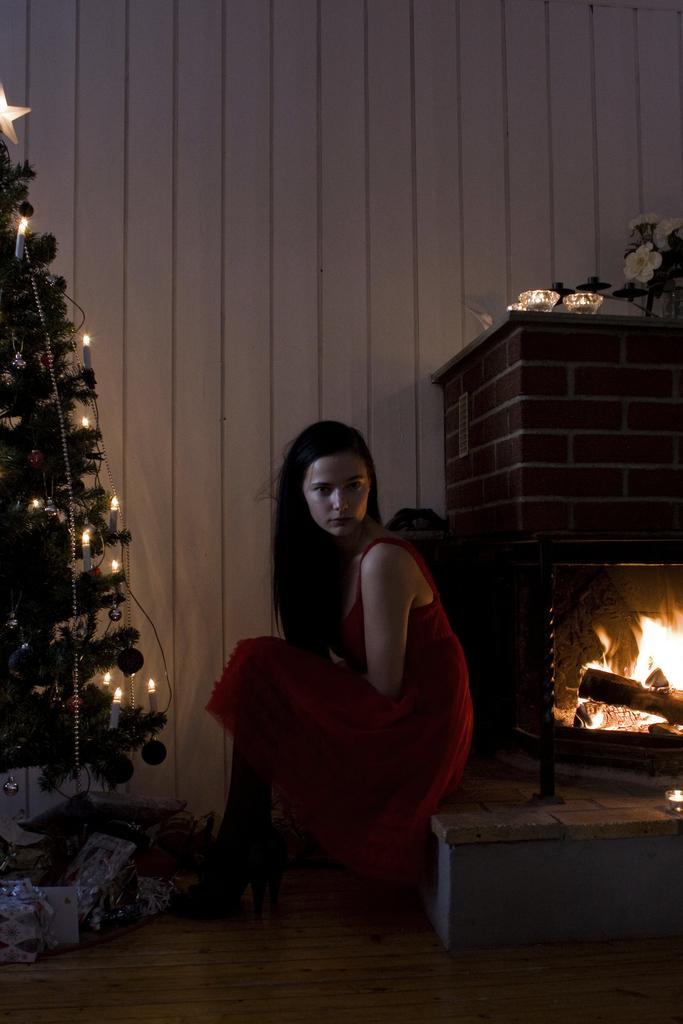Could you give a brief overview of what you see in this image? In this picture, there is a woman sitting, in front of her we can see Christmas tree with decorative items and few objects, behind her we can see fire in fire place and we can see flowers and glasses on the platform. In the background of the image it is white 